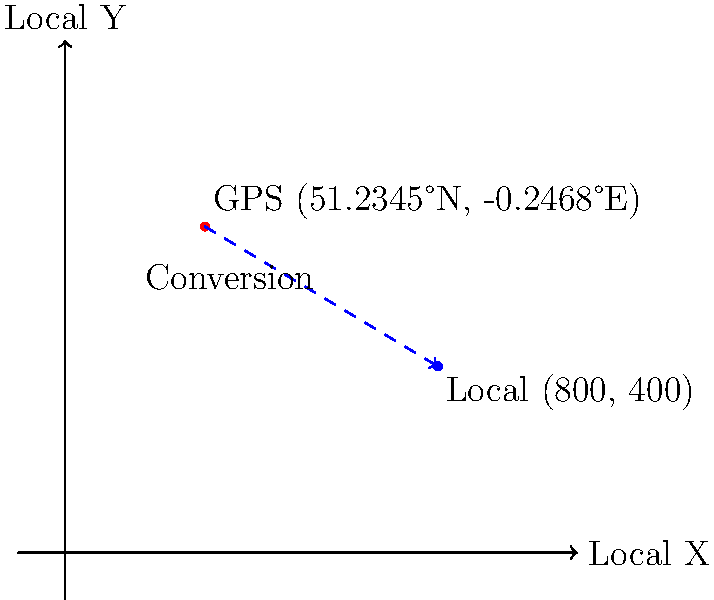As a meticulous travel scheduler in Earlswood, you need to convert GPS coordinates to the local coordinate system for precise travel time estimations. Given the GPS coordinates (51.2345°N, -0.2468°E) and knowing that the local origin (0,0) is at (51.2300°N, -0.2500°E) with each unit representing 100 meters, what are the approximate local coordinates (x,y) in meters? To convert GPS coordinates to the local coordinate system, we need to follow these steps:

1. Calculate the difference in latitude and longitude:
   $\Delta lat = 51.2345° - 51.2300° = 0.0045°$
   $\Delta lon = -0.2468° - (-0.2500°) = 0.0032°$

2. Convert the differences to meters:
   - 1° of latitude ≈ 111,000 meters
   - 1° of longitude at this latitude ≈ 111,000 * cos(51.2345°) ≈ 69,400 meters

   $\Delta y = 0.0045° * 111,000 m/° = 499.5 m$
   $\Delta x = 0.0032° * 69,400 m/° = 222.1 m$

3. Round to the nearest 100 meters (as per the local coordinate system):
   x ≈ 200 meters
   y ≈ 500 meters

4. Convert to local coordinate units (each unit = 100 meters):
   x = 200 / 100 = 2 units
   y = 500 / 100 = 5 units

Therefore, the approximate local coordinates are (2, 5) in the local coordinate system, which represents (200, 500) in meters.
Answer: (200, 500) meters 